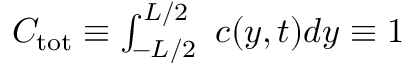<formula> <loc_0><loc_0><loc_500><loc_500>\begin{array} { r } { C _ { t o t } \equiv \int _ { - L / 2 } ^ { L / 2 } \ c ( y , t ) d y \equiv 1 } \end{array}</formula> 